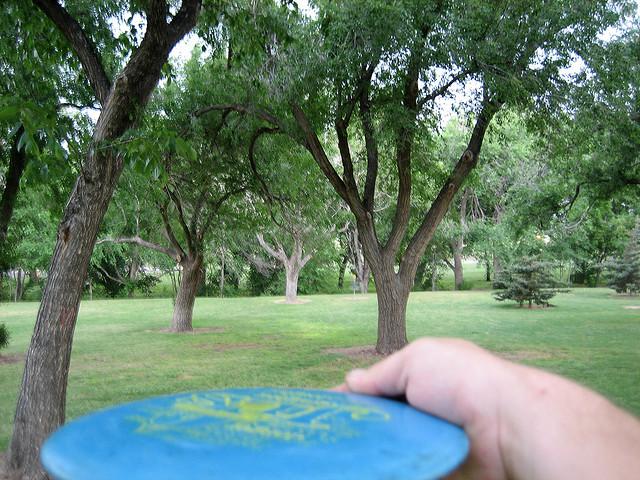Can this person throw the frisbee without hitting the trees?
Concise answer only. Yes. What color is the writing on the Frisbee?
Answer briefly. Yellow. Is the Frisbee player right handed or left handed?
Answer briefly. Right. 